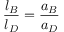Convert formula to latex. <formula><loc_0><loc_0><loc_500><loc_500>{ \frac { l _ { B } } { l _ { D } } } = { \frac { a _ { B } } { a _ { D } } }</formula> 